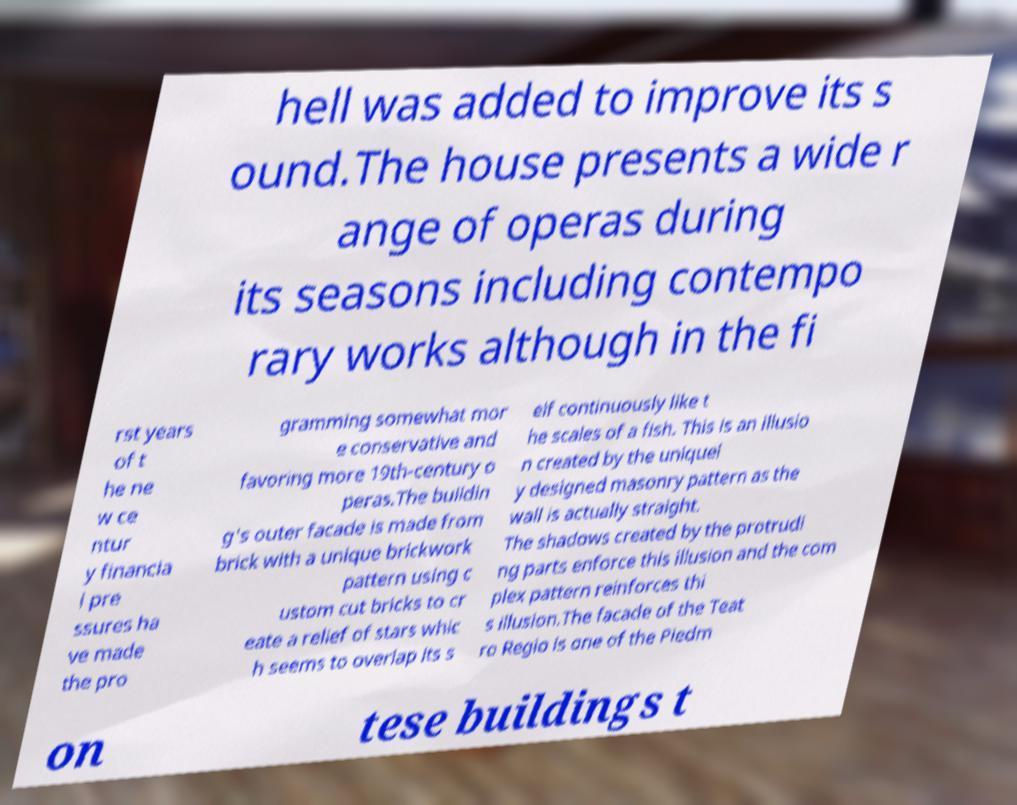Can you accurately transcribe the text from the provided image for me? hell was added to improve its s ound.The house presents a wide r ange of operas during its seasons including contempo rary works although in the fi rst years of t he ne w ce ntur y financia l pre ssures ha ve made the pro gramming somewhat mor e conservative and favoring more 19th-century o peras.The buildin g's outer facade is made from brick with a unique brickwork pattern using c ustom cut bricks to cr eate a relief of stars whic h seems to overlap its s elf continuously like t he scales of a fish. This is an illusio n created by the uniquel y designed masonry pattern as the wall is actually straight. The shadows created by the protrudi ng parts enforce this illusion and the com plex pattern reinforces thi s illusion.The facade of the Teat ro Regio is one of the Piedm on tese buildings t 